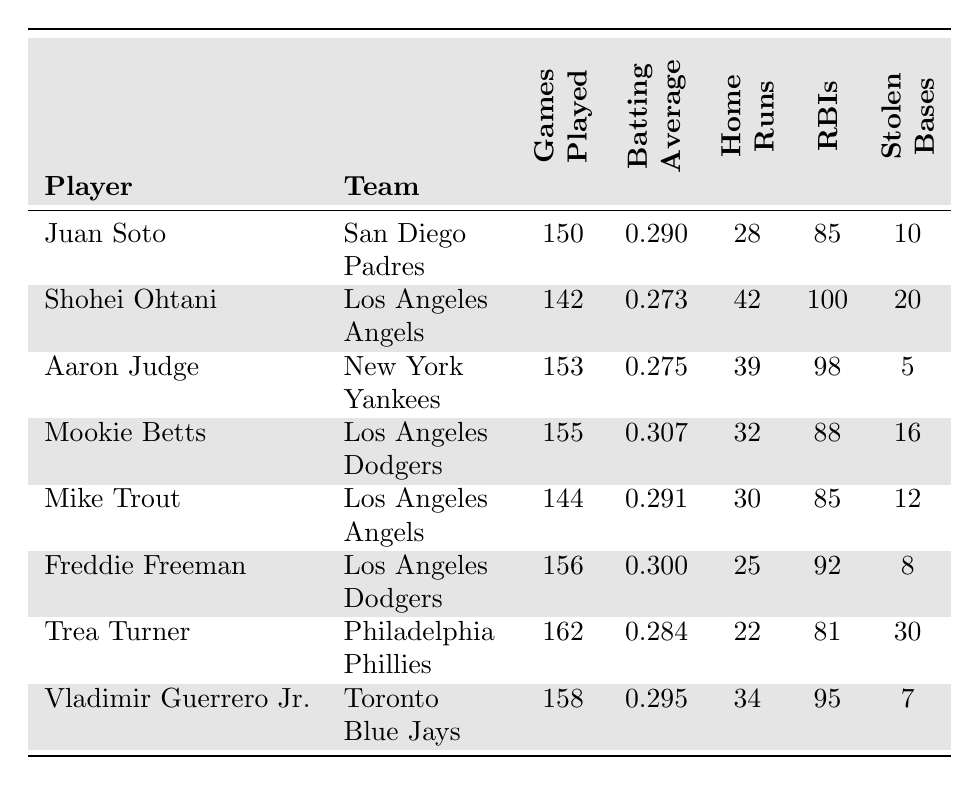What is Juan Soto's batting average? Juan Soto’s batting average is listed in the table, under the "Batting Average" column for his entry. It states 0.290.
Answer: 0.290 Who has the most home runs? By comparing the "Home Runs" column, Shohei Ohtani has the highest number with 42 home runs.
Answer: Shohei Ohtani How many RBIs did Aaron Judge have? The RBIs for Aaron Judge can be found in the "RBIs" column in his row, which indicates he had 98 RBIs.
Answer: 98 Calculate the total stolen bases for the Los Angeles Angels players. The players from the Los Angeles Angels are Shohei Ohtani and Mike Trout. Their stolen bases are 20 and 12 respectively. Adding these gives 20 + 12 = 32.
Answer: 32 Who has the lowest batting average among the listed players? Looking across the "Batting Average" column, Shohei Ohtani has the lowest value at 0.273.
Answer: Shohei Ohtani What is the difference in home runs between Juan Soto and Mike Trout? Juan Soto has 28 home runs and Mike Trout has 30. The difference is calculated as 30 - 28 = 2.
Answer: 2 What is the average number of games played for all players? To find the average, sum the "Games Played" column values: 150 + 142 + 153 + 155 + 144 + 156 + 162 + 158 = 1,120. Divide by the total number of players (8): 1,120 / 8 = 140.
Answer: 140 Is Mookie Betts' batting average above .300? Mookie Betts’ batting average, found in the table, is 0.307, which is above 0.300.
Answer: Yes Which player has the highest RBIs and how many? By reviewing the "RBIs" column, Shohei Ohtani has the highest with 100 RBIs.
Answer: Shohei Ohtani, 100 How many home runs do Mike Trout and Vladimir Guerrero Jr. have combined? Mike Trout has 30 home runs, and Vladimir Guerrero Jr. has 34. Adding these gives 30 + 34 = 64.
Answer: 64 